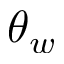<formula> <loc_0><loc_0><loc_500><loc_500>\theta _ { w }</formula> 